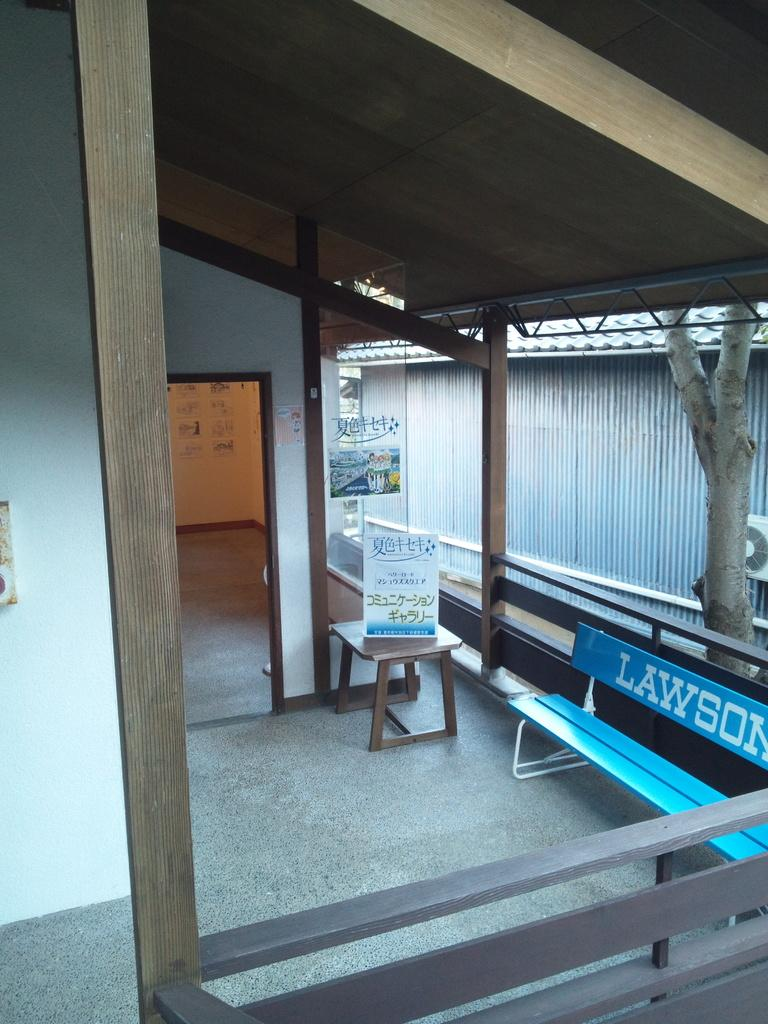<image>
Offer a succinct explanation of the picture presented. Area with a blue bench that says Lawson on it. 